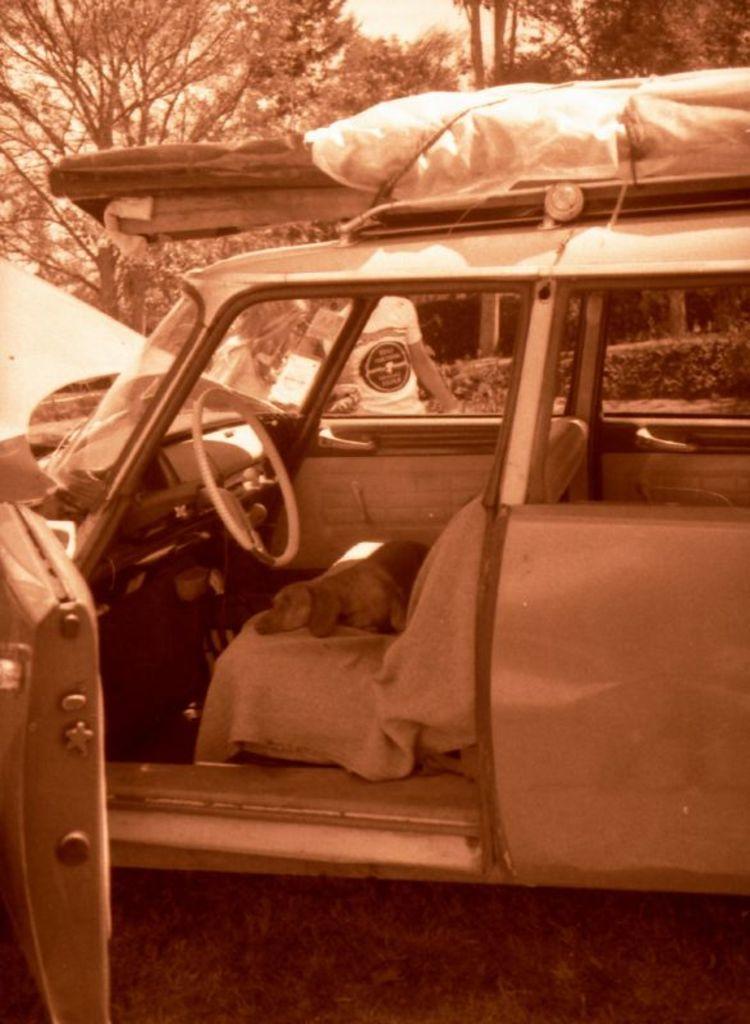Describe this image in one or two sentences. This is a black and white picture. Here we can see a vehicle and there is a dog. In the background we can see a person, plants, trees, and sky. 